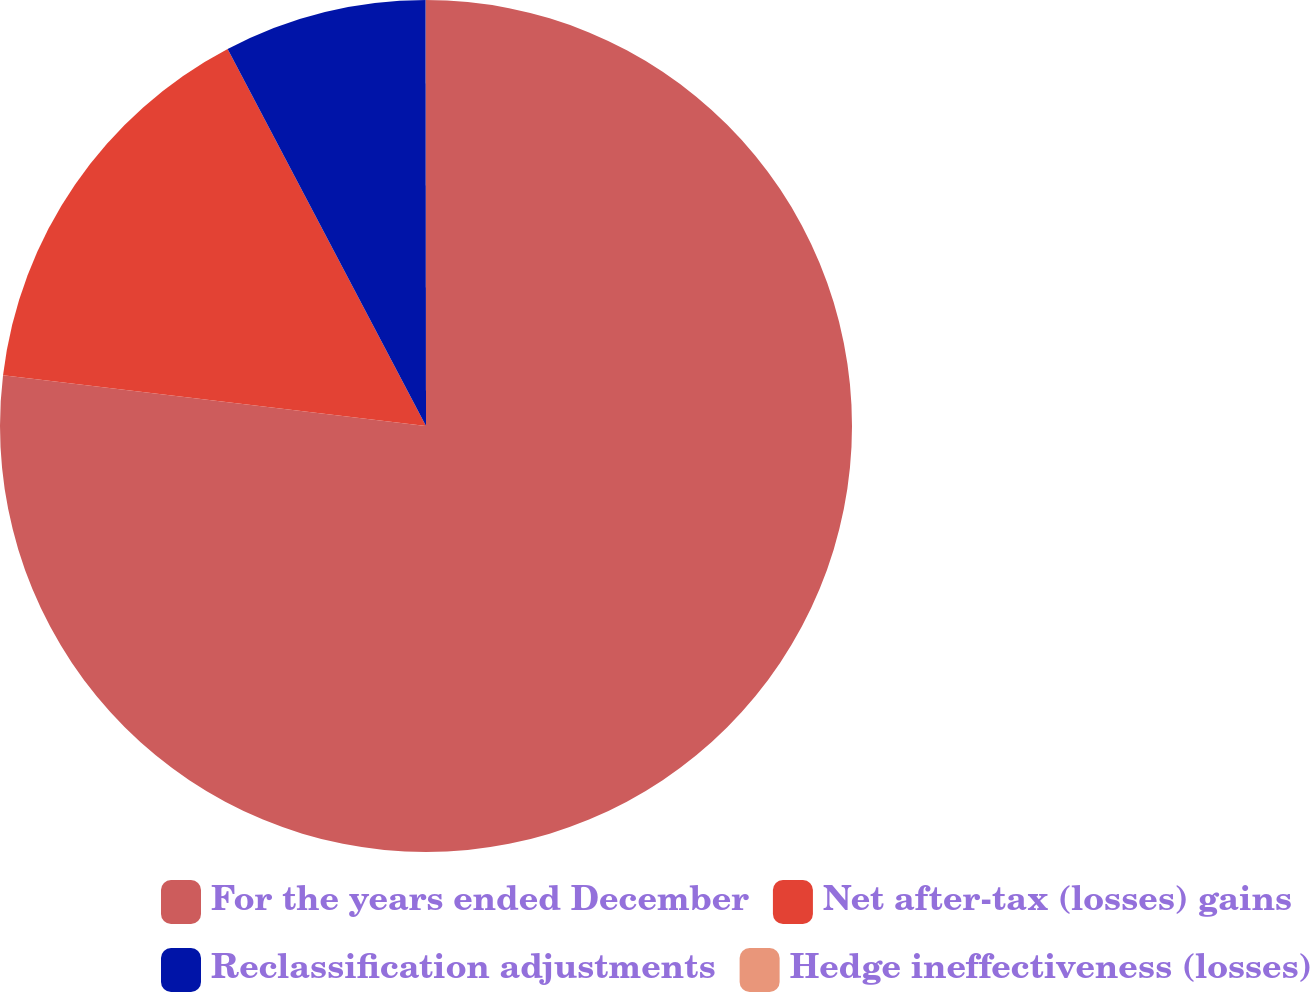Convert chart. <chart><loc_0><loc_0><loc_500><loc_500><pie_chart><fcel>For the years ended December<fcel>Net after-tax (losses) gains<fcel>Reclassification adjustments<fcel>Hedge ineffectiveness (losses)<nl><fcel>76.91%<fcel>15.39%<fcel>7.7%<fcel>0.01%<nl></chart> 